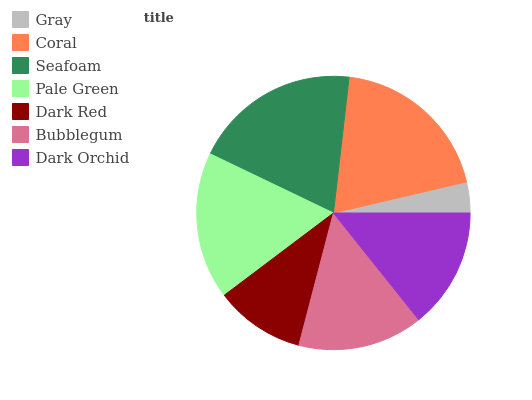Is Gray the minimum?
Answer yes or no. Yes. Is Seafoam the maximum?
Answer yes or no. Yes. Is Coral the minimum?
Answer yes or no. No. Is Coral the maximum?
Answer yes or no. No. Is Coral greater than Gray?
Answer yes or no. Yes. Is Gray less than Coral?
Answer yes or no. Yes. Is Gray greater than Coral?
Answer yes or no. No. Is Coral less than Gray?
Answer yes or no. No. Is Bubblegum the high median?
Answer yes or no. Yes. Is Bubblegum the low median?
Answer yes or no. Yes. Is Gray the high median?
Answer yes or no. No. Is Coral the low median?
Answer yes or no. No. 